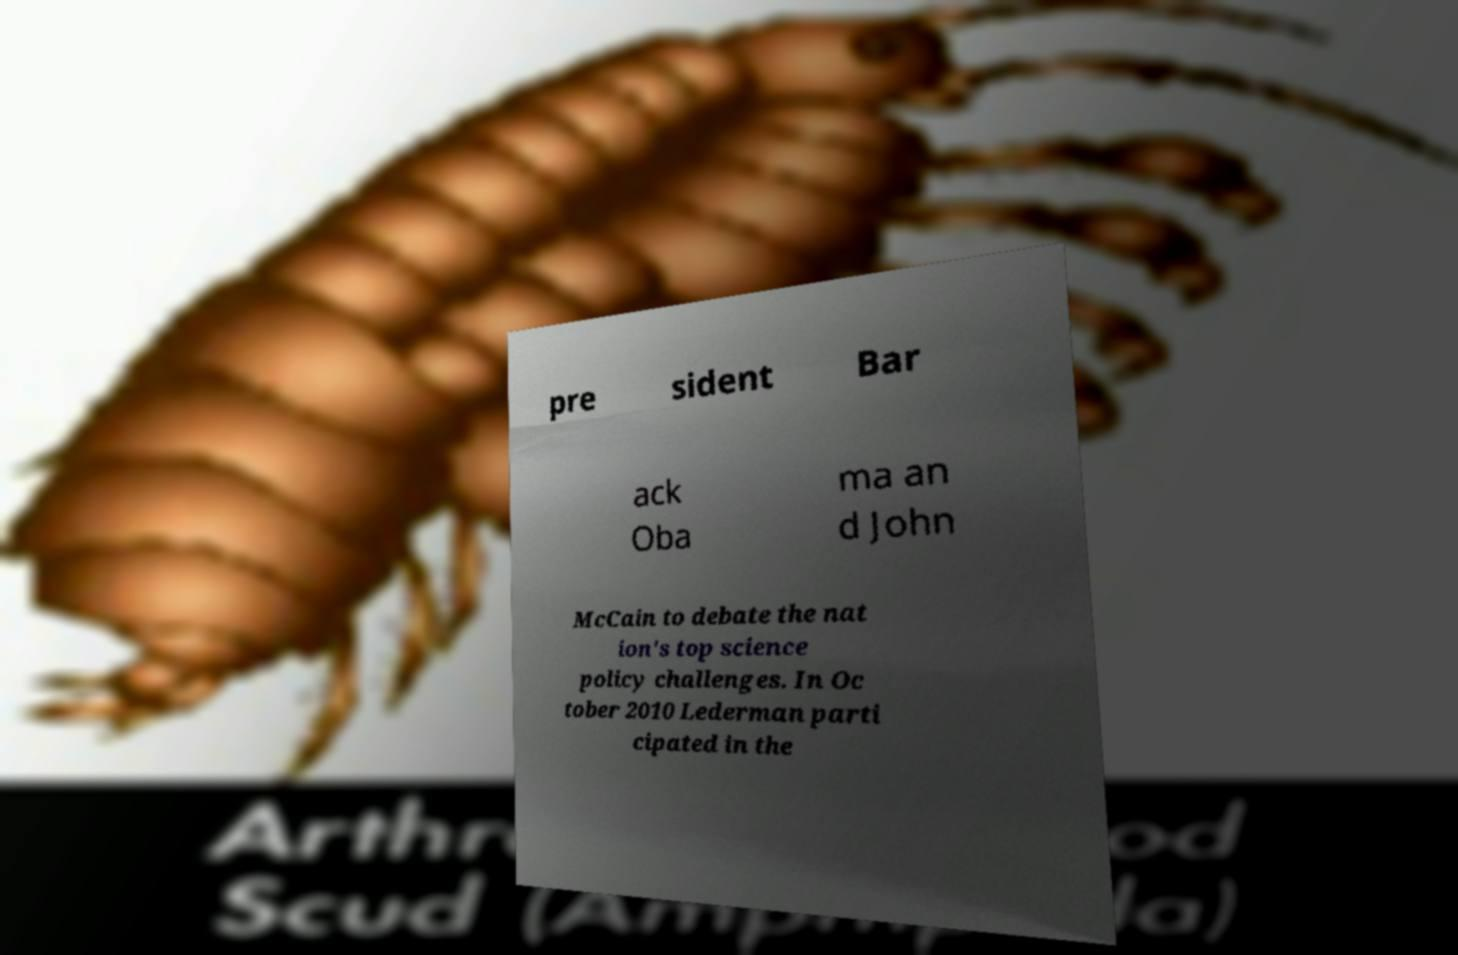Can you accurately transcribe the text from the provided image for me? pre sident Bar ack Oba ma an d John McCain to debate the nat ion's top science policy challenges. In Oc tober 2010 Lederman parti cipated in the 